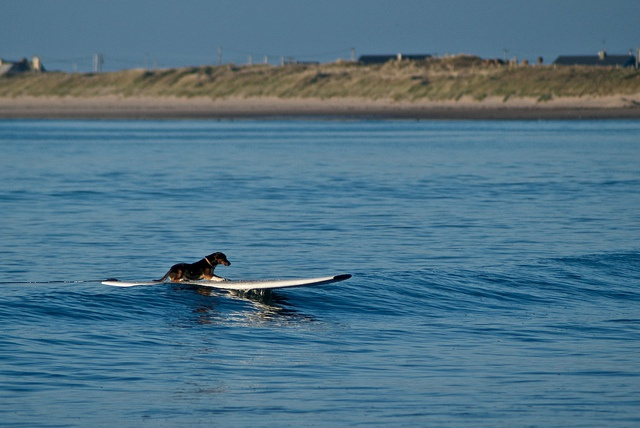Describe the objects in this image and their specific colors. I can see surfboard in gray, beige, darkgray, and black tones and dog in gray, black, maroon, and brown tones in this image. 